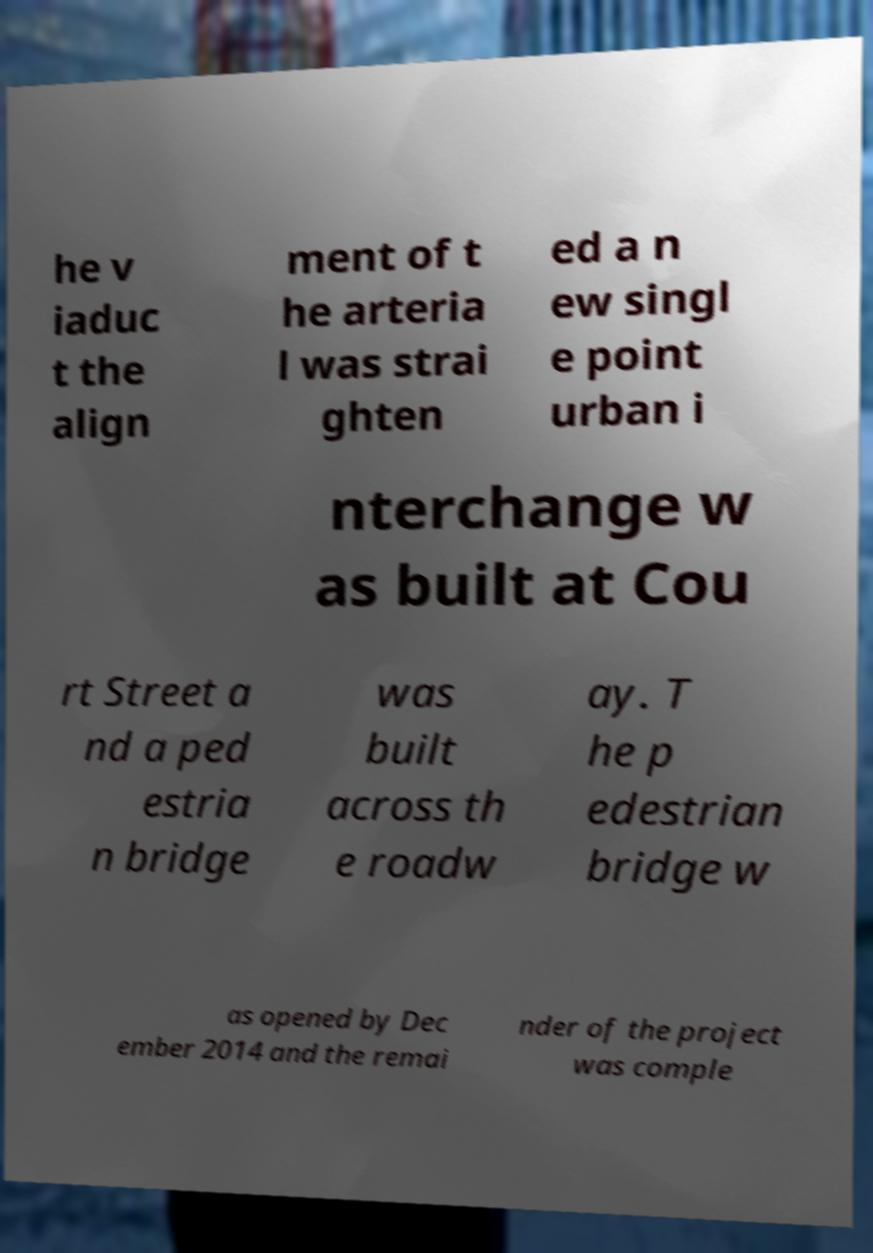Could you assist in decoding the text presented in this image and type it out clearly? he v iaduc t the align ment of t he arteria l was strai ghten ed a n ew singl e point urban i nterchange w as built at Cou rt Street a nd a ped estria n bridge was built across th e roadw ay. T he p edestrian bridge w as opened by Dec ember 2014 and the remai nder of the project was comple 